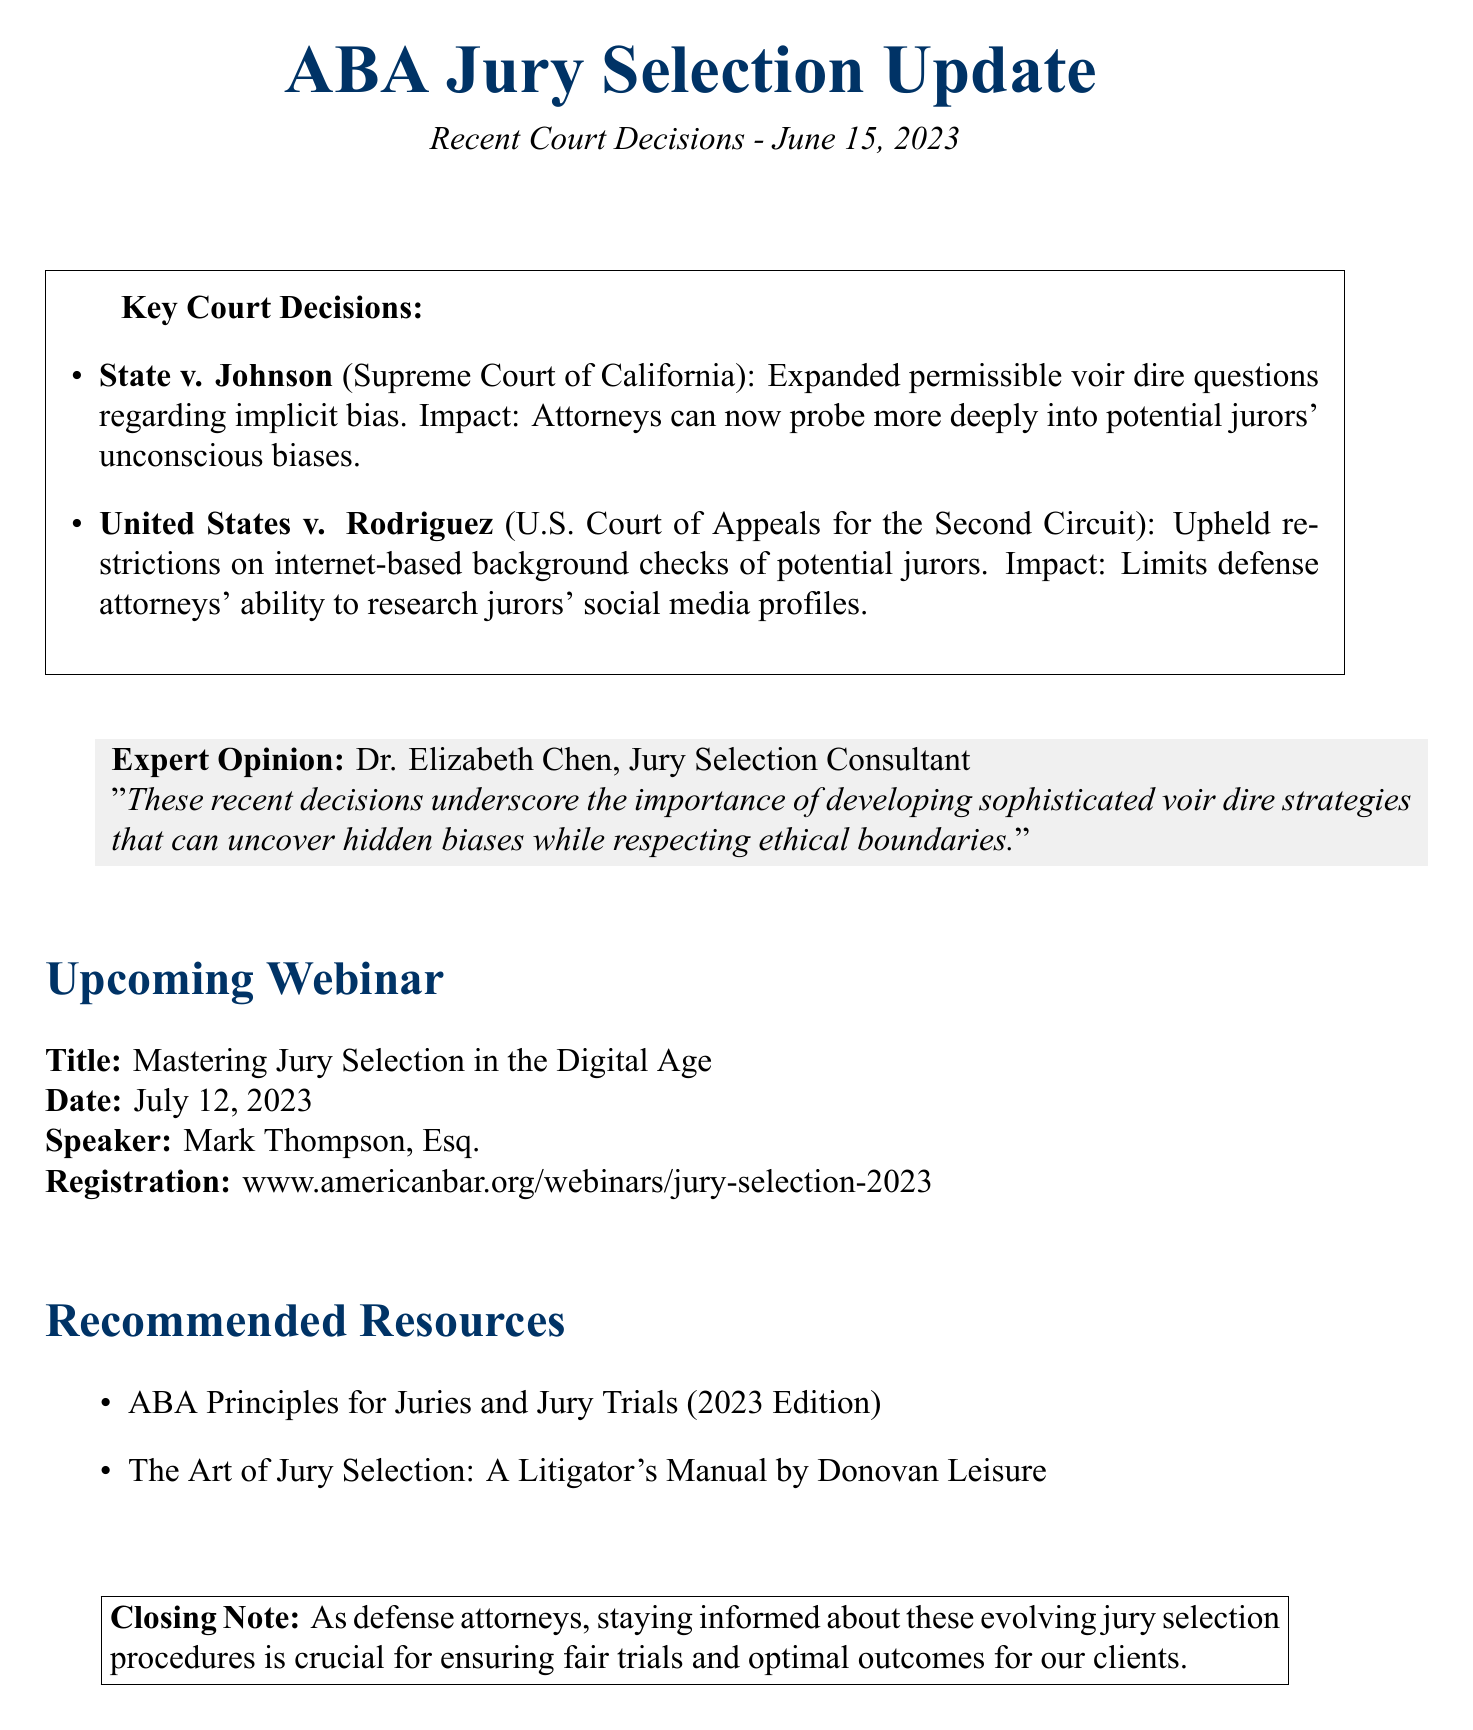What is the title of the newsletter? The title of the newsletter is mentioned in the header of the document.
Answer: ABA Jury Selection Update: Recent Court Decisions When was the newsletter published? The publication date is clearly stated at the beginning of the document.
Answer: June 15, 2023 What is the ruling in State v. Johnson? The document details key court decisions, including the ruling of this specific case.
Answer: Expanded permissible voir dire questions regarding implicit bias Who is the speaker for the upcoming webinar? The speaker's name is listed under the webinar details in the document.
Answer: Mark Thompson, Esq What is the impact of the ruling in United States v. Rodriguez? The document explains the effect of the ruling on defense attorneys' practices.
Answer: Limits defense attorneys' ability to research jurors' social media profiles What is the expert opinion on jury selection strategies? The document quotes a jury selection consultant, summarizing the importance of strategies in light of recent decisions.
Answer: Developing sophisticated voir dire strategies that can uncover hidden biases while respecting ethical boundaries What is the date of the upcoming webinar? The date is specified in the webinar section of the document.
Answer: July 12, 2023 What are the recommended resources listed in the document? The document includes a section listing recommended resources for further reading.
Answer: ABA Principles for Juries and Jury Trials (2023 Edition), The Art of Jury Selection: A Litigator's Manual by Donovan Leisure 